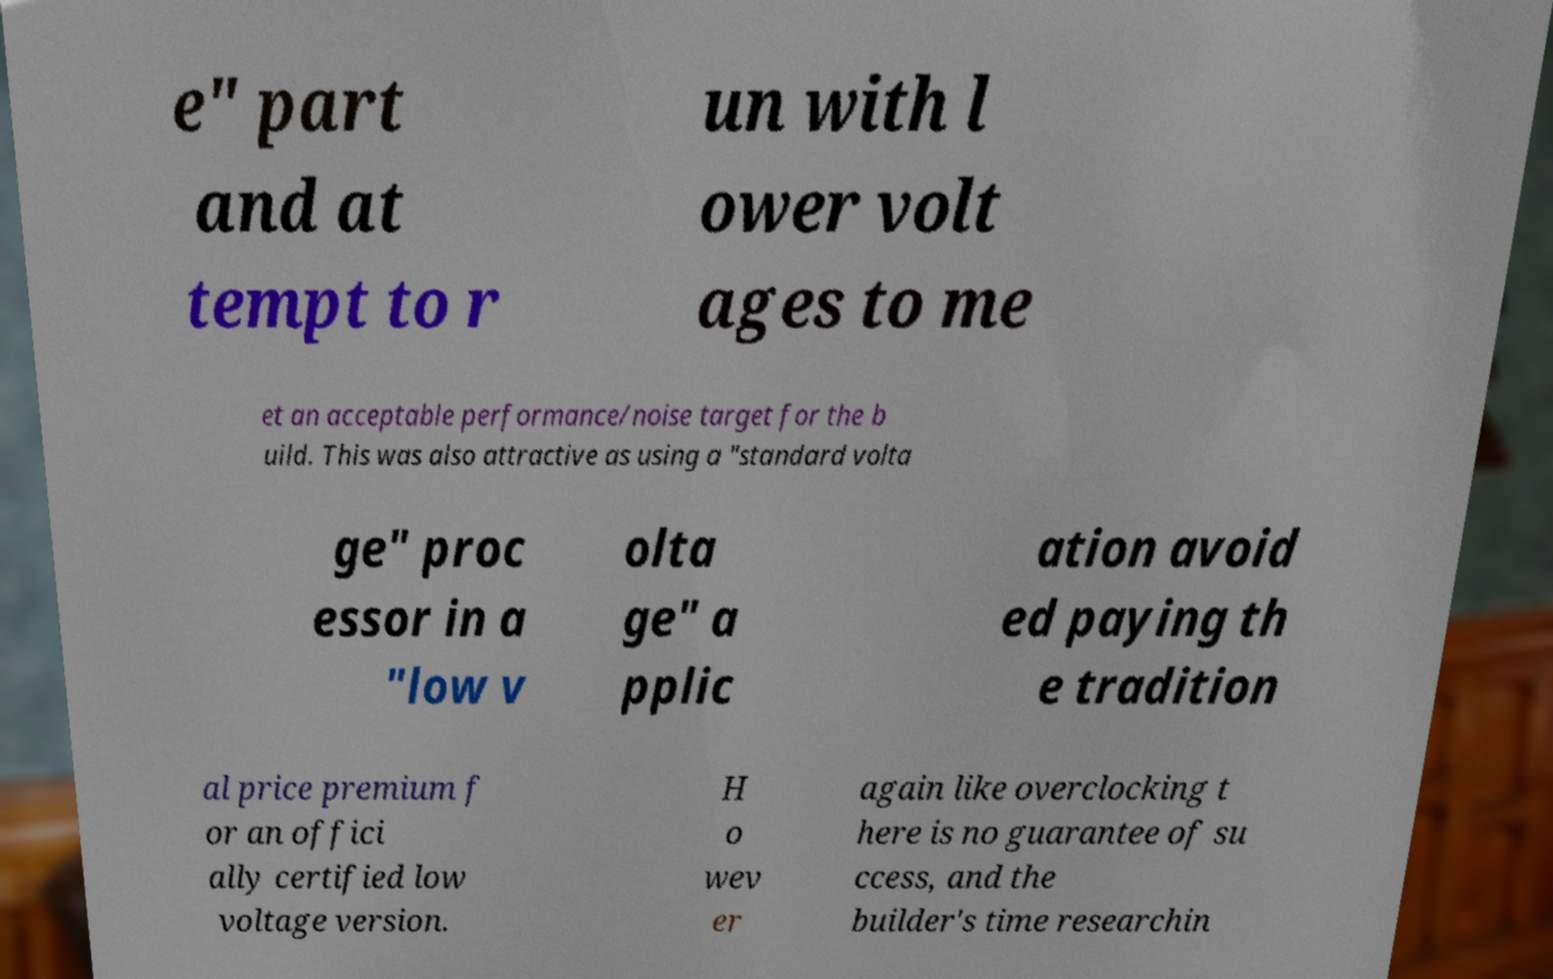There's text embedded in this image that I need extracted. Can you transcribe it verbatim? e" part and at tempt to r un with l ower volt ages to me et an acceptable performance/noise target for the b uild. This was also attractive as using a "standard volta ge" proc essor in a "low v olta ge" a pplic ation avoid ed paying th e tradition al price premium f or an offici ally certified low voltage version. H o wev er again like overclocking t here is no guarantee of su ccess, and the builder's time researchin 